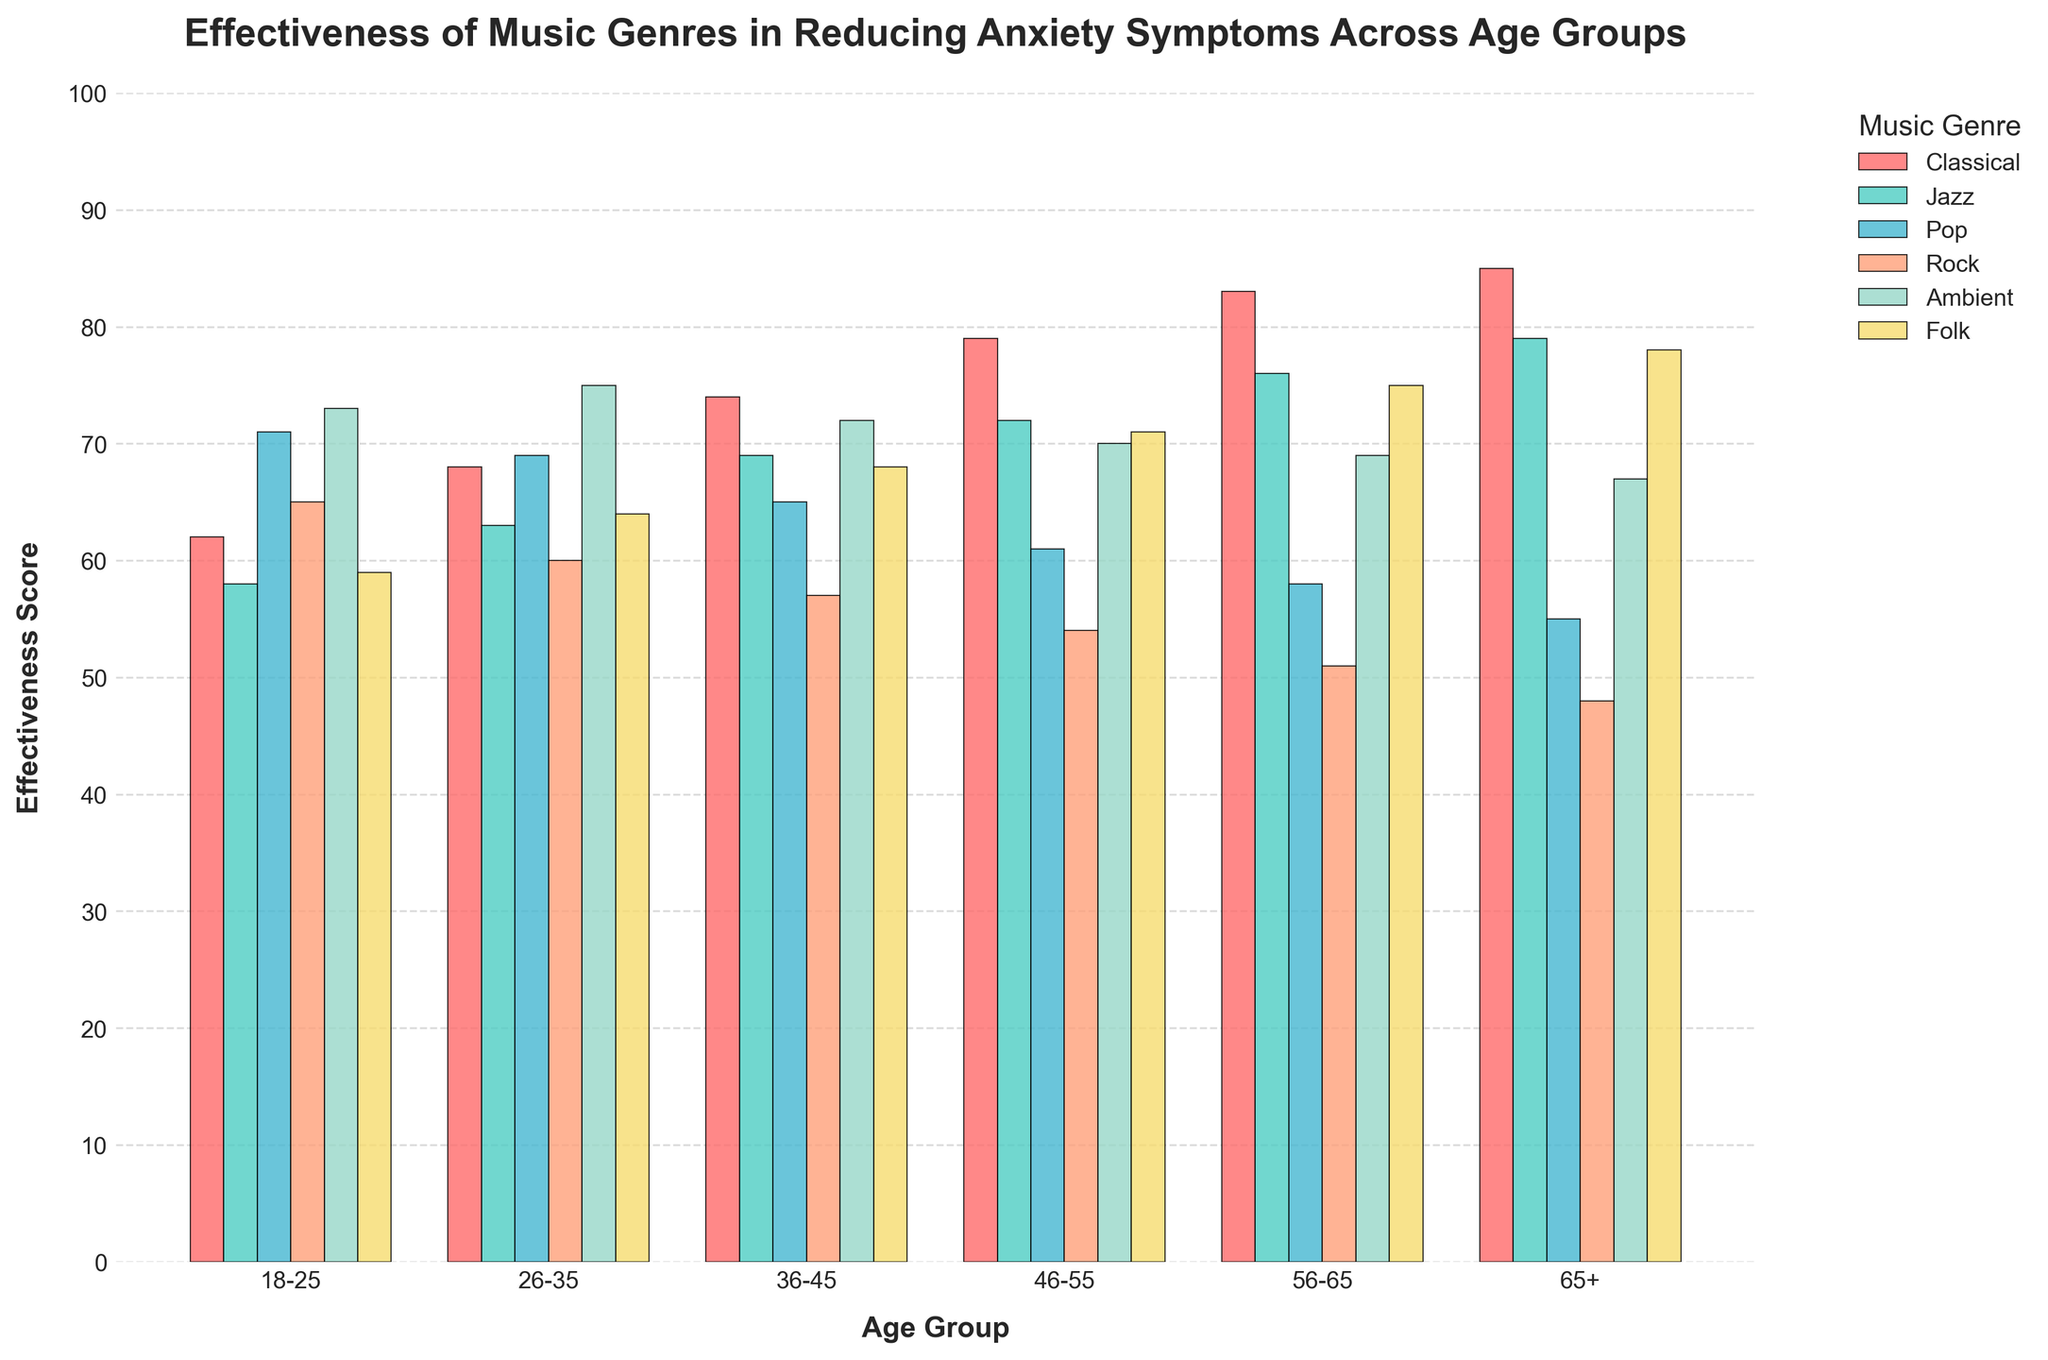What is the most effective music genre for the 65+ age group? By observing the heights of the bars for each music genre in the 65+ age group, we see that Folk has the highest effectiveness score, which indicates it is the most effective genre for this age group.
Answer: Folk Which age group finds Classical music most effective in reducing anxiety? Looking at the heights of the Classical music bars across all age groups, the 65+ age group has the tallest bar, which shows that this age group finds Classical music most effective in reducing anxiety.
Answer: 65+ How does the effectiveness of Ambient music compare between the 18-25 and 26-35 age groups? By comparing the heights of the Ambient music bars for the 18-25 and 26-35 age groups, we can see that the bar for the 26-35 age group is slightly taller, indicating higher effectiveness in this age group.
Answer: 26-35 age group finds it more effective What is the average effectiveness score of Pop music across all age groups? To find the average, add the effectiveness scores of Pop music for all age groups (71 + 69 + 65 + 61 + 58 + 55), which totals to 379, and then divide by the number of age groups (6): 379 / 6.
Answer: 63.17 Which music genre has the steepest decrease in effectiveness from the 26-35 to 56-65 age group? One way to identify the steepest decrease is to calculate the differences in effectiveness scores between the 26-35 and 56-65 age groups for all music genres. The differences are:
Classical: 83 - 68 = 15
Jazz: 76 - 63 = 13
Pop: 58 - 69 = -11
Rock: 51 - 60 = -9
Ambient: 69 - 75 = 6
Folk: 75 - 64 = 11
Rock has the steepest decrease as -9 is the largest negative difference.
Answer: Rock How much more effective is Folk music for the 46-55 age group compared to the 18-25 age group? Subtract the effectiveness score of the 18-25 age group from the effectiveness score of the 46-55 age group for Folk music: 71 - 59.
Answer: 12 points For the age group 36-45, which music genre has almost the same effectiveness score as Pop music in the 26-35 age group? The Pop music score in the 26-35 age group is 69. In the 36-45 age group, Jazz has an effectiveness score of 69, matching the Pop score of the 26-35 age group.
Answer: Jazz 